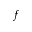<formula> <loc_0><loc_0><loc_500><loc_500>f</formula> 